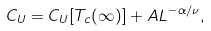Convert formula to latex. <formula><loc_0><loc_0><loc_500><loc_500>C _ { U } = C _ { U } [ T _ { c } ( \infty ) ] + A L ^ { - \alpha / \nu } ,</formula> 